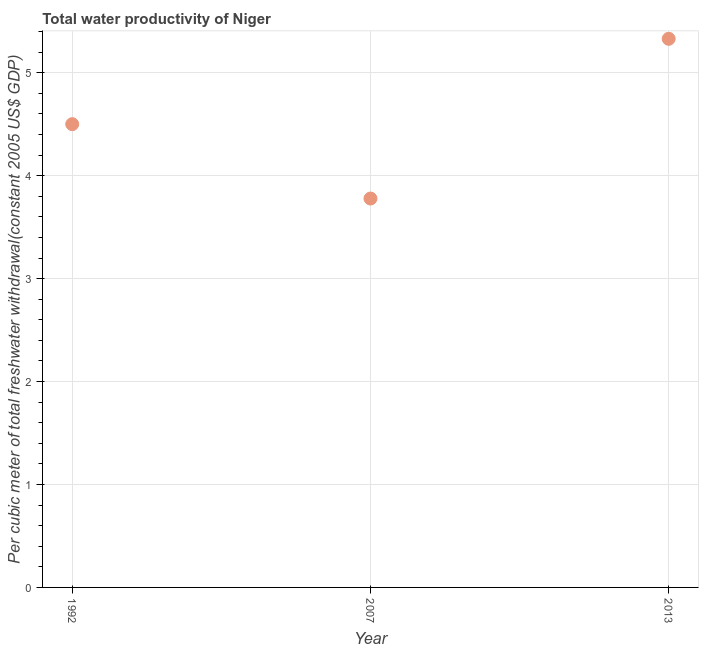What is the total water productivity in 1992?
Offer a very short reply. 4.5. Across all years, what is the maximum total water productivity?
Your answer should be very brief. 5.33. Across all years, what is the minimum total water productivity?
Offer a terse response. 3.78. What is the sum of the total water productivity?
Provide a succinct answer. 13.61. What is the difference between the total water productivity in 1992 and 2013?
Offer a very short reply. -0.83. What is the average total water productivity per year?
Offer a terse response. 4.54. What is the median total water productivity?
Offer a terse response. 4.5. What is the ratio of the total water productivity in 1992 to that in 2013?
Make the answer very short. 0.84. Is the total water productivity in 1992 less than that in 2013?
Your answer should be compact. Yes. Is the difference between the total water productivity in 1992 and 2013 greater than the difference between any two years?
Give a very brief answer. No. What is the difference between the highest and the second highest total water productivity?
Offer a very short reply. 0.83. Is the sum of the total water productivity in 1992 and 2007 greater than the maximum total water productivity across all years?
Ensure brevity in your answer.  Yes. What is the difference between the highest and the lowest total water productivity?
Provide a succinct answer. 1.55. In how many years, is the total water productivity greater than the average total water productivity taken over all years?
Your answer should be very brief. 1. Does the total water productivity monotonically increase over the years?
Make the answer very short. No. What is the difference between two consecutive major ticks on the Y-axis?
Provide a short and direct response. 1. Are the values on the major ticks of Y-axis written in scientific E-notation?
Provide a short and direct response. No. Does the graph contain any zero values?
Ensure brevity in your answer.  No. Does the graph contain grids?
Provide a succinct answer. Yes. What is the title of the graph?
Your answer should be compact. Total water productivity of Niger. What is the label or title of the X-axis?
Provide a short and direct response. Year. What is the label or title of the Y-axis?
Give a very brief answer. Per cubic meter of total freshwater withdrawal(constant 2005 US$ GDP). What is the Per cubic meter of total freshwater withdrawal(constant 2005 US$ GDP) in 1992?
Make the answer very short. 4.5. What is the Per cubic meter of total freshwater withdrawal(constant 2005 US$ GDP) in 2007?
Offer a very short reply. 3.78. What is the Per cubic meter of total freshwater withdrawal(constant 2005 US$ GDP) in 2013?
Your response must be concise. 5.33. What is the difference between the Per cubic meter of total freshwater withdrawal(constant 2005 US$ GDP) in 1992 and 2007?
Provide a succinct answer. 0.72. What is the difference between the Per cubic meter of total freshwater withdrawal(constant 2005 US$ GDP) in 1992 and 2013?
Give a very brief answer. -0.83. What is the difference between the Per cubic meter of total freshwater withdrawal(constant 2005 US$ GDP) in 2007 and 2013?
Your response must be concise. -1.55. What is the ratio of the Per cubic meter of total freshwater withdrawal(constant 2005 US$ GDP) in 1992 to that in 2007?
Provide a short and direct response. 1.19. What is the ratio of the Per cubic meter of total freshwater withdrawal(constant 2005 US$ GDP) in 1992 to that in 2013?
Your response must be concise. 0.84. What is the ratio of the Per cubic meter of total freshwater withdrawal(constant 2005 US$ GDP) in 2007 to that in 2013?
Give a very brief answer. 0.71. 